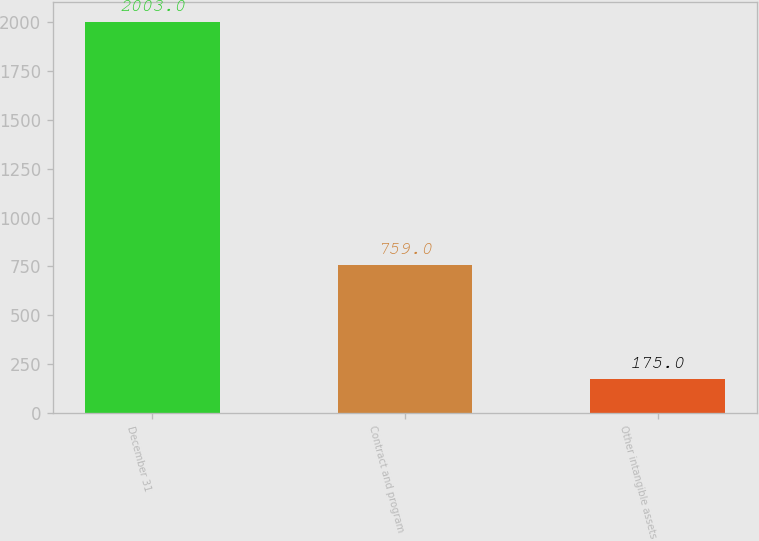Convert chart. <chart><loc_0><loc_0><loc_500><loc_500><bar_chart><fcel>December 31<fcel>Contract and program<fcel>Other intangible assets<nl><fcel>2003<fcel>759<fcel>175<nl></chart> 